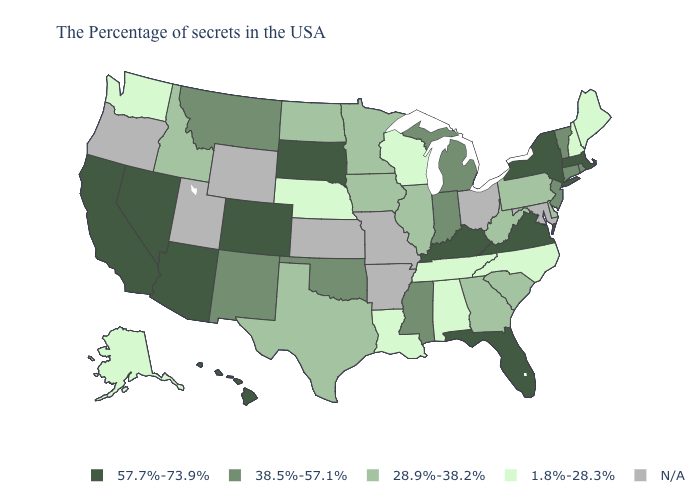What is the value of Nevada?
Be succinct. 57.7%-73.9%. Name the states that have a value in the range 28.9%-38.2%?
Answer briefly. Delaware, Pennsylvania, South Carolina, West Virginia, Georgia, Illinois, Minnesota, Iowa, Texas, North Dakota, Idaho. Name the states that have a value in the range 1.8%-28.3%?
Answer briefly. Maine, New Hampshire, North Carolina, Alabama, Tennessee, Wisconsin, Louisiana, Nebraska, Washington, Alaska. How many symbols are there in the legend?
Keep it brief. 5. What is the value of Georgia?
Keep it brief. 28.9%-38.2%. What is the value of New Mexico?
Answer briefly. 38.5%-57.1%. Does Alaska have the highest value in the USA?
Concise answer only. No. Is the legend a continuous bar?
Quick response, please. No. Does Louisiana have the highest value in the South?
Short answer required. No. What is the value of Delaware?
Write a very short answer. 28.9%-38.2%. Among the states that border Oklahoma , which have the lowest value?
Write a very short answer. Texas. Name the states that have a value in the range 1.8%-28.3%?
Give a very brief answer. Maine, New Hampshire, North Carolina, Alabama, Tennessee, Wisconsin, Louisiana, Nebraska, Washington, Alaska. What is the value of Wisconsin?
Quick response, please. 1.8%-28.3%. Among the states that border Mississippi , which have the lowest value?
Concise answer only. Alabama, Tennessee, Louisiana. 